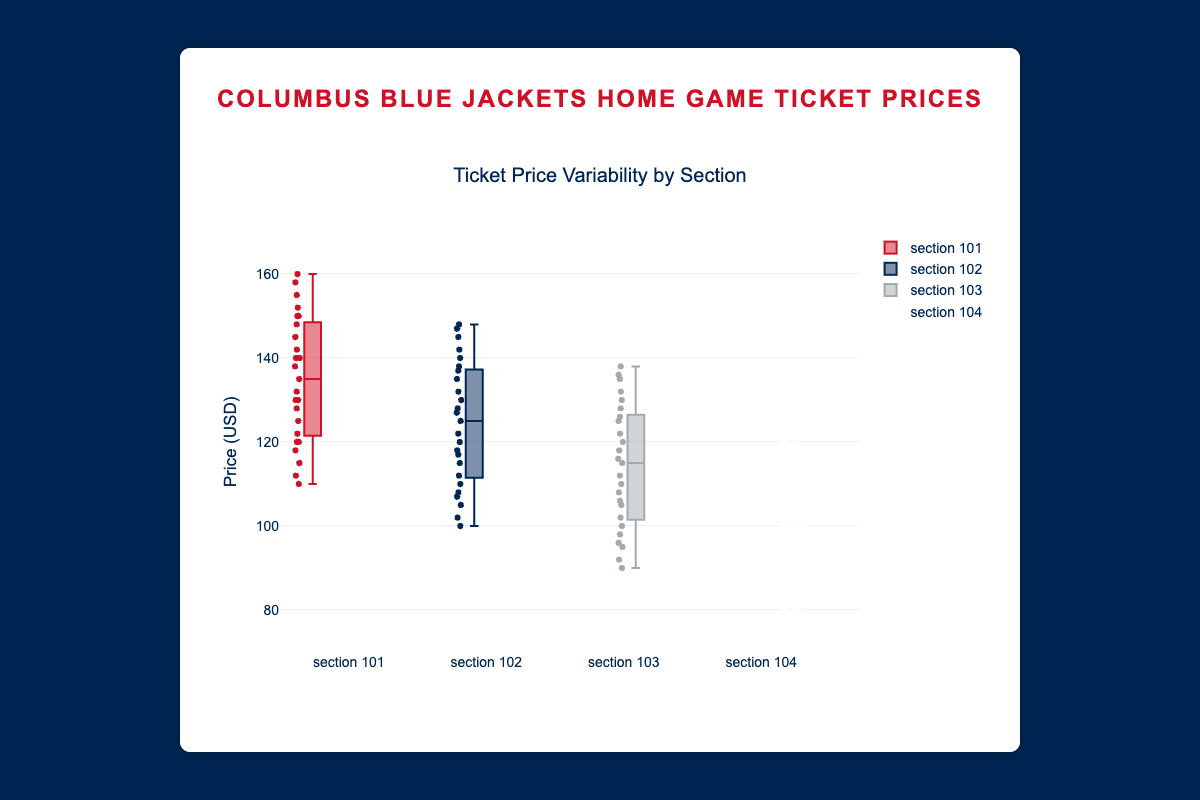What is the title of the figure? The title is located at the top of the figure. It's often a phrase summarizing what the plot represents. In this case, it’s given directly in the code as "Ticket Price Variability by Section".
Answer: Ticket Price Variability by Section Which section has the highest ticket price range? The sections are displayed side by side with their range depicted within each box plot. Compare the length of the boxes to determine the range. Section 101 generally shows the highest ticket price range.
Answer: Section 101 What’s the median ticket price for Section 103? The median is represented by a line within each box. By examining Section 103, you can see where the line is located within the box.
Answer: 115 Which section shows the least variability in ticket prices? Variability is indicated by the length of the box plot—the shorter the box, the lesser the variability. Section 104 has the smallest box plot length indicating the least variability.
Answer: Section 104 In which section is the median ticket price the highest? The median, or middle line within the box, needs to be looked at for each section. Section 101 shows the highest median line.
Answer: Section 101 What is the interquartile range (IQR) for ticket prices in Section 102? The IQR is the difference between the first quartile (bottom of the box) and the third quartile (top of the box). Note these positions on the box plot and calculate the difference for Section 102.
Answer: 32 Which two sections have the closest median ticket prices? Examine the median lines within each section’s box plot and compare their values to find the closest medians. Sections 102 and 103 have median lines that are quite close to each other.
Answer: Section 102 and Section 103 Compare the upper whiskers of Section 101 and Section 104. Which one is higher? The upper whisker represents the maximum value excluding outliers. By visually comparing, the upper whisker of Section 101 is higher than that of Section 104.
Answer: Section 101 What is the price range for Section 101? The price range is the difference between the maximum and minimum values. The top of the upper whisker and the bottom of the lower whisker in Section 101 need to be noted and subtracted.
Answer: 40 How do the box plots reflect the effect of opponent teams on ticket prices? To determine this, note the width and height of each box plot and whiskers for each section. The varying box plot heights and whiskers indicate the effect of different opponent teams on ticket price variation.
Answer: Varying lengths and heights reflect the effect 